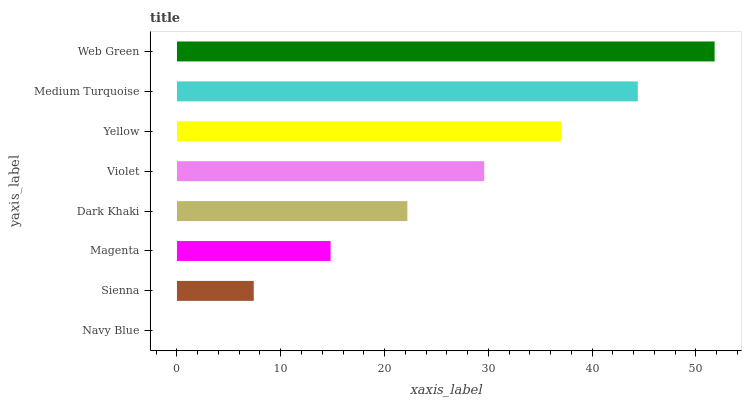Is Navy Blue the minimum?
Answer yes or no. Yes. Is Web Green the maximum?
Answer yes or no. Yes. Is Sienna the minimum?
Answer yes or no. No. Is Sienna the maximum?
Answer yes or no. No. Is Sienna greater than Navy Blue?
Answer yes or no. Yes. Is Navy Blue less than Sienna?
Answer yes or no. Yes. Is Navy Blue greater than Sienna?
Answer yes or no. No. Is Sienna less than Navy Blue?
Answer yes or no. No. Is Violet the high median?
Answer yes or no. Yes. Is Dark Khaki the low median?
Answer yes or no. Yes. Is Web Green the high median?
Answer yes or no. No. Is Sienna the low median?
Answer yes or no. No. 